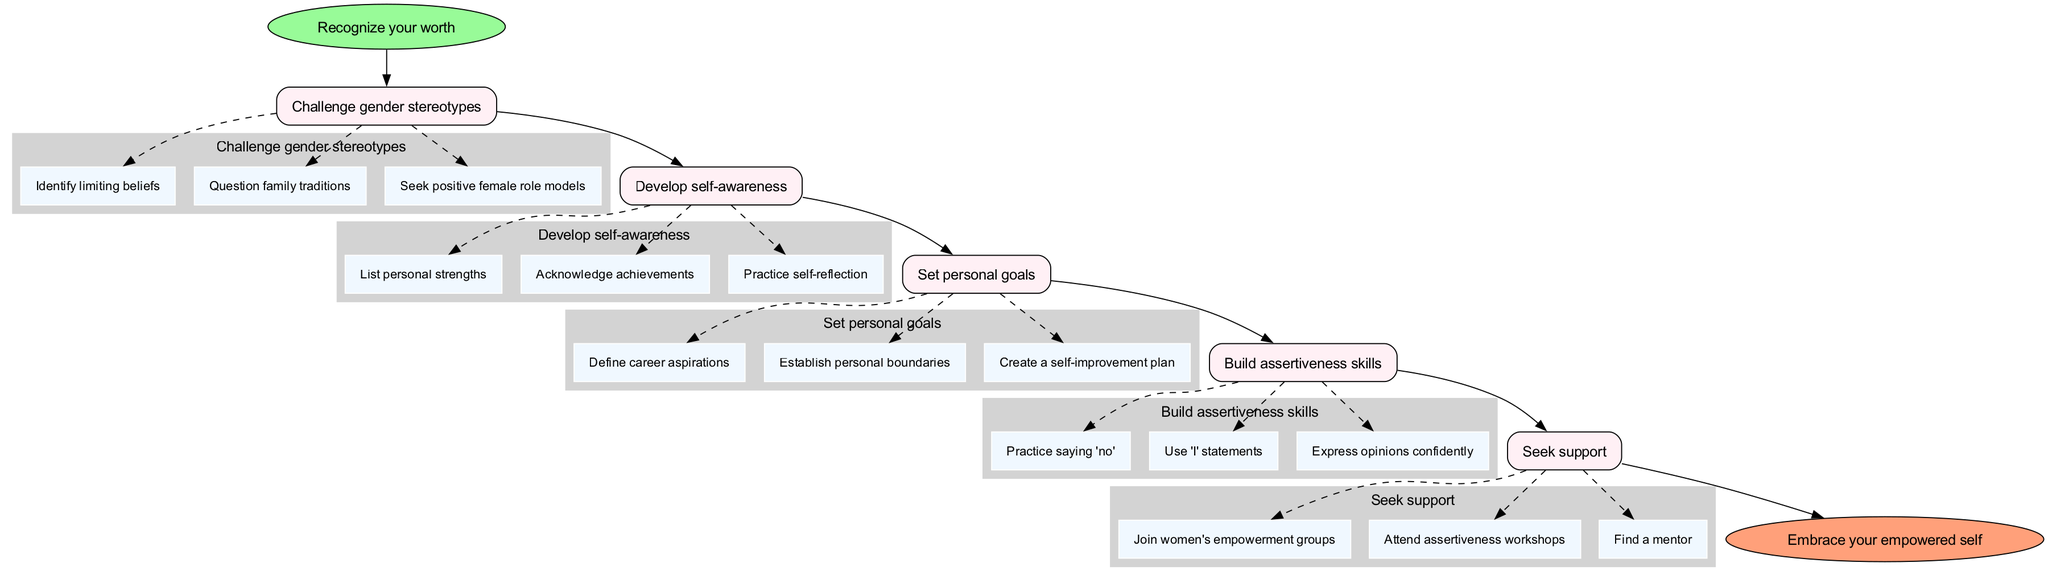What is the starting point of the guide? The guide begins with the step labeled "Recognize your worth," which is the first node in the diagram.
Answer: Recognize your worth How many main steps are there in the diagram? Counting the main steps listed in the diagram, we see there are five main steps outlined that guide the process.
Answer: 5 What does the last step of the guide lead to? The last main step of the guide directly connects to the endpoint, which is labeled "Embrace your empowered self."
Answer: Embrace your empowered self What is one of the substeps under "Build assertiveness skills"? Under the "Build assertiveness skills" step, one of the substeps included is "Practice saying 'no'."
Answer: Practice saying 'no' What are two substeps listed under "Develop self-awareness"? The substeps listed under "Develop self-awareness" include "List personal strengths" and "Acknowledge achievements." By identifying these items from the substeps, we can answer the question.
Answer: List personal strengths; Acknowledge achievements What is the relationship between "Challenge gender stereotypes" and "Develop self-awareness"? "Challenge gender stereotypes" is the first main step in the diagram and is connected directly to "Develop self-awareness," which is the following step. This means once you complete one, you move to the next.
Answer: Directly connected How many substeps does "Seek support" have? The "Seek support" step has three substeps listed, confirming that this is the number of actions to take under it.
Answer: 3 What is the shape used for the start and end points in the diagram? The starting point "Recognize your worth" is represented by an ellipse shape, while the ending point "Embrace your empowered self" is also represented by an ellipse shape.
Answer: Ellipse What would you need to do after "Set personal goals"? After completing the "Set personal goals" step, the next step you would move on to is "Build assertiveness skills," which follows in the progression of the diagram.
Answer: Build assertiveness skills 